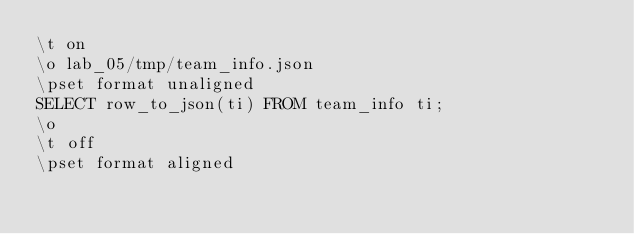<code> <loc_0><loc_0><loc_500><loc_500><_SQL_>\t on
\o lab_05/tmp/team_info.json
\pset format unaligned
SELECT row_to_json(ti) FROM team_info ti;
\o
\t off
\pset format aligned
</code> 